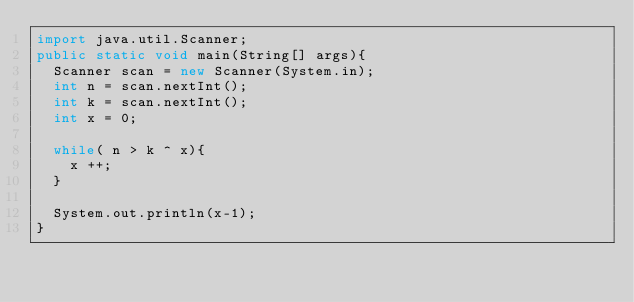<code> <loc_0><loc_0><loc_500><loc_500><_Java_>import java.util.Scanner;
public static void main(String[] args){
  Scanner scan = new Scanner(System.in);
  int n = scan.nextInt();
  int k = scan.nextInt();
  int x = 0;
  
  while( n > k ^ x){
    x ++;
  }
  
  System.out.println(x-1);
}</code> 